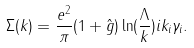Convert formula to latex. <formula><loc_0><loc_0><loc_500><loc_500>\Sigma ( k ) = \frac { e ^ { 2 } } { \pi } ( 1 + \hat { g } ) \ln ( \frac { \Lambda } { k } ) i k _ { i } \gamma _ { i } .</formula> 